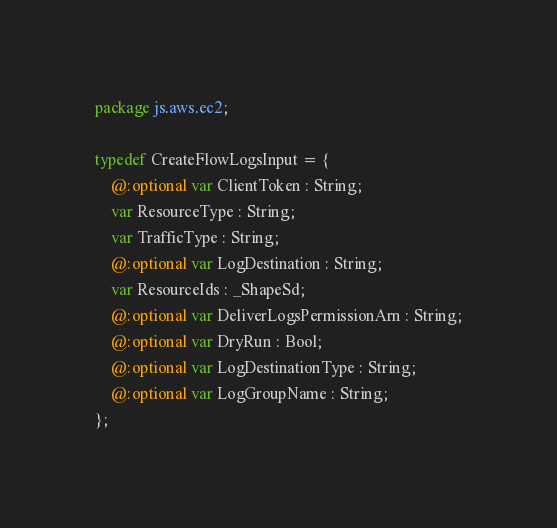Convert code to text. <code><loc_0><loc_0><loc_500><loc_500><_Haxe_>package js.aws.ec2;

typedef CreateFlowLogsInput = {
    @:optional var ClientToken : String;
    var ResourceType : String;
    var TrafficType : String;
    @:optional var LogDestination : String;
    var ResourceIds : _ShapeSd;
    @:optional var DeliverLogsPermissionArn : String;
    @:optional var DryRun : Bool;
    @:optional var LogDestinationType : String;
    @:optional var LogGroupName : String;
};
</code> 